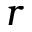Convert formula to latex. <formula><loc_0><loc_0><loc_500><loc_500>r</formula> 